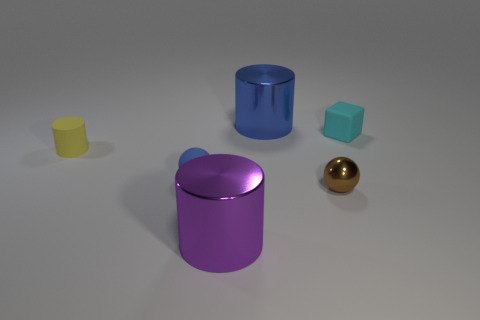What number of objects are either large gray shiny cubes or tiny objects that are left of the cyan thing?
Your answer should be very brief. 3. Do the thing in front of the small brown ball and the small blue matte thing have the same shape?
Offer a terse response. No. How many big purple cylinders are to the left of the tiny sphere on the left side of the small brown thing that is on the right side of the small yellow cylinder?
Give a very brief answer. 0. Is there anything else that has the same shape as the yellow thing?
Your response must be concise. Yes. What number of objects are either shiny things or big gray matte blocks?
Give a very brief answer. 3. Is the shape of the yellow matte object the same as the blue object left of the large purple cylinder?
Offer a very short reply. No. Is the number of tiny things the same as the number of small red shiny spheres?
Your answer should be very brief. No. There is a large object in front of the tiny brown metal thing; what shape is it?
Your response must be concise. Cylinder. Is the blue shiny thing the same shape as the large purple shiny thing?
Give a very brief answer. Yes. What size is the other object that is the same shape as the brown metallic object?
Provide a short and direct response. Small. 